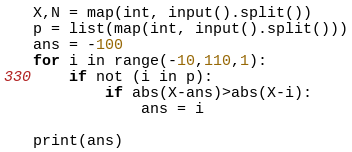Convert code to text. <code><loc_0><loc_0><loc_500><loc_500><_Python_>X,N = map(int, input().split())
p = list(map(int, input().split()))
ans = -100
for i in range(-10,110,1):
    if not (i in p):
        if abs(X-ans)>abs(X-i):
            ans = i

print(ans)</code> 